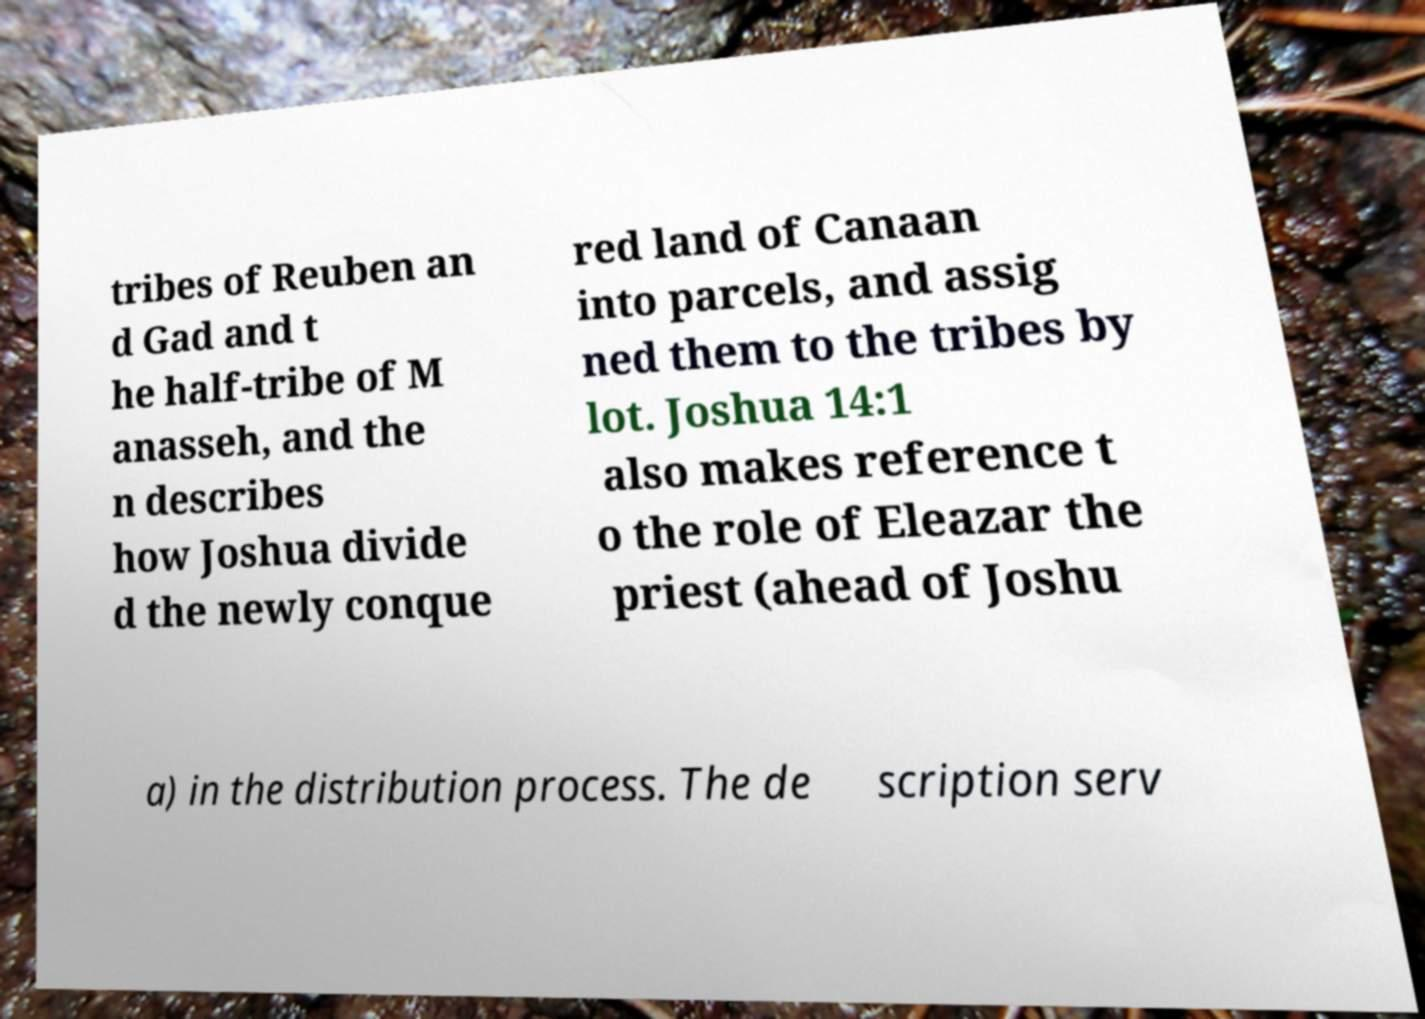What messages or text are displayed in this image? I need them in a readable, typed format. tribes of Reuben an d Gad and t he half-tribe of M anasseh, and the n describes how Joshua divide d the newly conque red land of Canaan into parcels, and assig ned them to the tribes by lot. Joshua 14:1 also makes reference t o the role of Eleazar the priest (ahead of Joshu a) in the distribution process. The de scription serv 